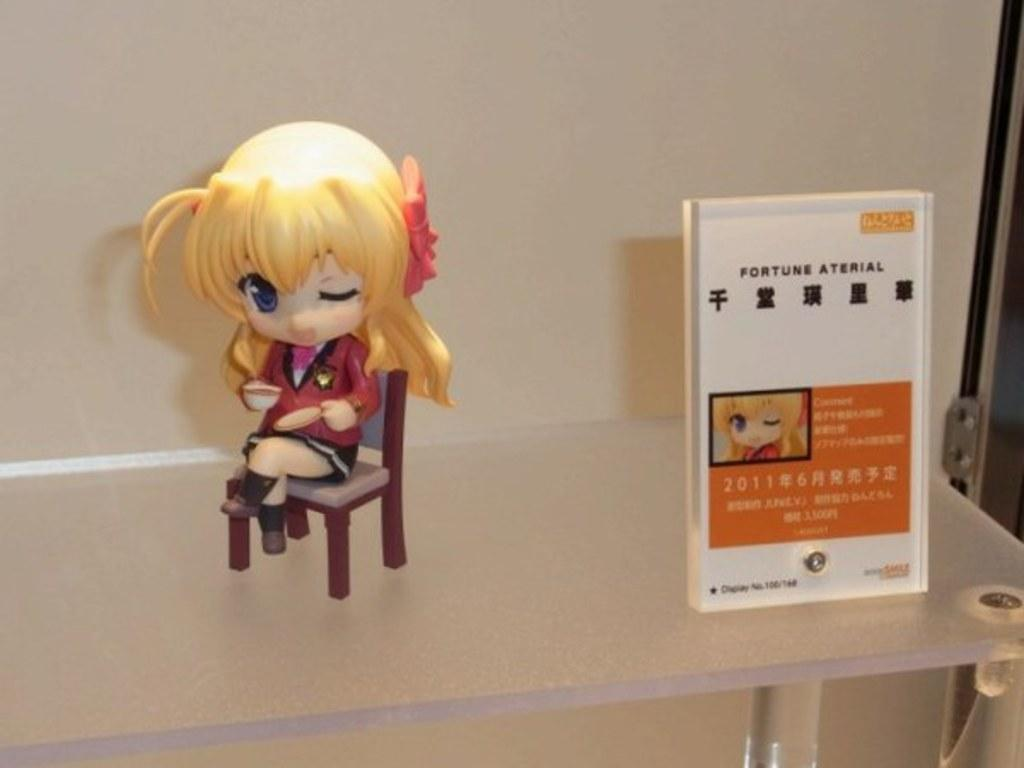What is the main subject of the image? There is a doll in the image. Where is the doll located in the image? The doll is sitting on a chair. What can be seen on the right side of the image? There is a card on the right side of the image. What information does the card provide about the doll? The card describes the doll. What type of cake is being served at the lake in the image? There is no cake or lake present in the image; it features a doll sitting on a chair with a card describing it. 